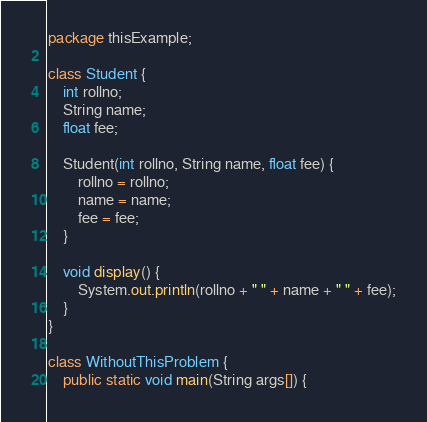<code> <loc_0><loc_0><loc_500><loc_500><_Java_>package thisExample;

class Student {
	int rollno;
	String name;
	float fee;

	Student(int rollno, String name, float fee) {
		rollno = rollno;
		name = name;
		fee = fee;
	}

	void display() {
		System.out.println(rollno + " " + name + " " + fee);
	}
}

class WithoutThisProblem {
	public static void main(String args[]) {</code> 